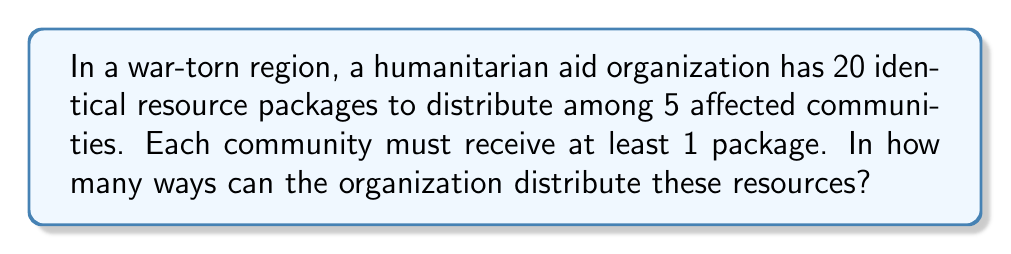What is the answer to this math problem? This problem can be solved using the concept of Stars and Bars (also known as Balls and Urns) in combinatorics.

Step 1: Reformulate the problem
We need to find the number of ways to place 15 dividers among 20 objects, as we have already allocated 1 package to each of the 5 communities (20 - 5 = 15 remaining packages).

Step 2: Apply the Stars and Bars formula
The formula for this scenario is:

$${n+k-1 \choose k-1}$$

Where $n$ is the number of identical objects (remaining packages) and $k$ is the number of groups (communities).

In this case, $n = 15$ and $k = 5$.

Step 3: Substitute the values
$${15+5-1 \choose 5-1} = {19 \choose 4}$$

Step 4: Calculate the combination
$${19 \choose 4} = \frac{19!}{4!(19-4)!} = \frac{19!}{4!15!}$$

Step 5: Simplify
$$\frac{19 \times 18 \times 17 \times 16}{4 \times 3 \times 2 \times 1} = 3876$$

Therefore, there are 3876 ways to distribute the resources among the affected communities.
Answer: 3876 